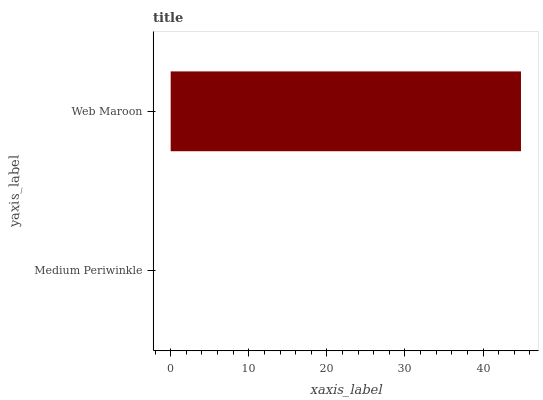Is Medium Periwinkle the minimum?
Answer yes or no. Yes. Is Web Maroon the maximum?
Answer yes or no. Yes. Is Web Maroon the minimum?
Answer yes or no. No. Is Web Maroon greater than Medium Periwinkle?
Answer yes or no. Yes. Is Medium Periwinkle less than Web Maroon?
Answer yes or no. Yes. Is Medium Periwinkle greater than Web Maroon?
Answer yes or no. No. Is Web Maroon less than Medium Periwinkle?
Answer yes or no. No. Is Web Maroon the high median?
Answer yes or no. Yes. Is Medium Periwinkle the low median?
Answer yes or no. Yes. Is Medium Periwinkle the high median?
Answer yes or no. No. Is Web Maroon the low median?
Answer yes or no. No. 